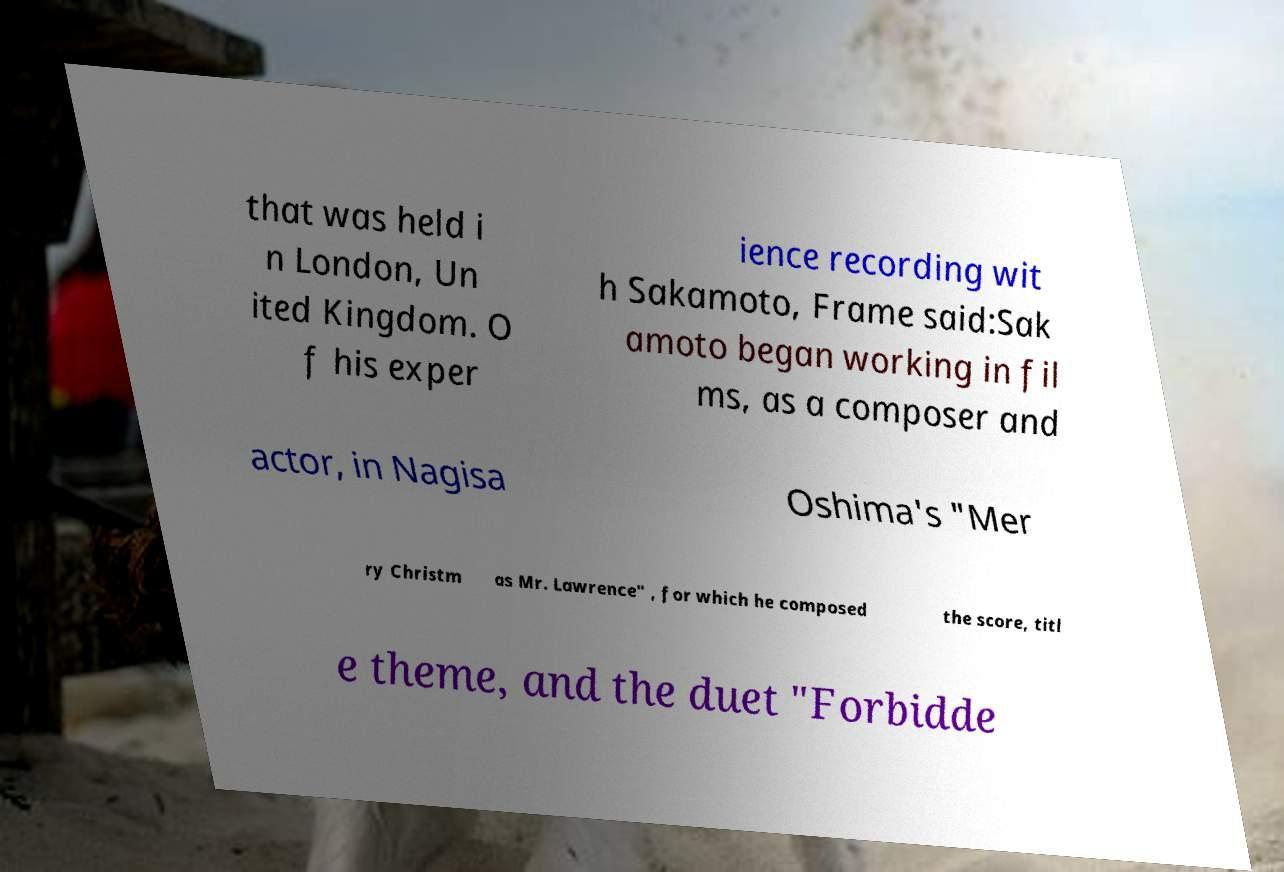There's text embedded in this image that I need extracted. Can you transcribe it verbatim? that was held i n London, Un ited Kingdom. O f his exper ience recording wit h Sakamoto, Frame said:Sak amoto began working in fil ms, as a composer and actor, in Nagisa Oshima's "Mer ry Christm as Mr. Lawrence" , for which he composed the score, titl e theme, and the duet "Forbidde 